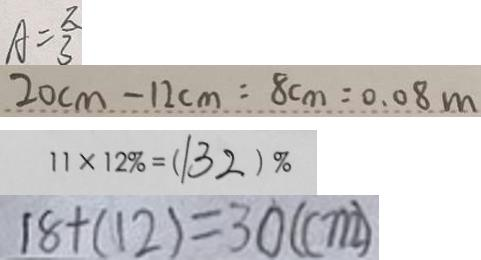<formula> <loc_0><loc_0><loc_500><loc_500>A = \frac { \pi } { 3 } 
 2 0 c m - 1 2 c m = 8 c m = 0 . 0 8 m 
 1 1 \times 1 2 \% = ( 1 3 2 ) \% 
 1 8 + ( 1 2 ) = 3 0 ( c m )</formula> 